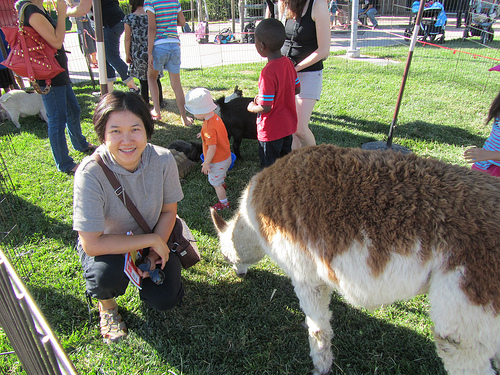Please provide the bounding box coordinate of the region this sentence describes: person has brown and pink purse. The bounding box coordinates for the region where the person has a brown and pink purse are [0.18, 0.42, 0.4, 0.67]. 